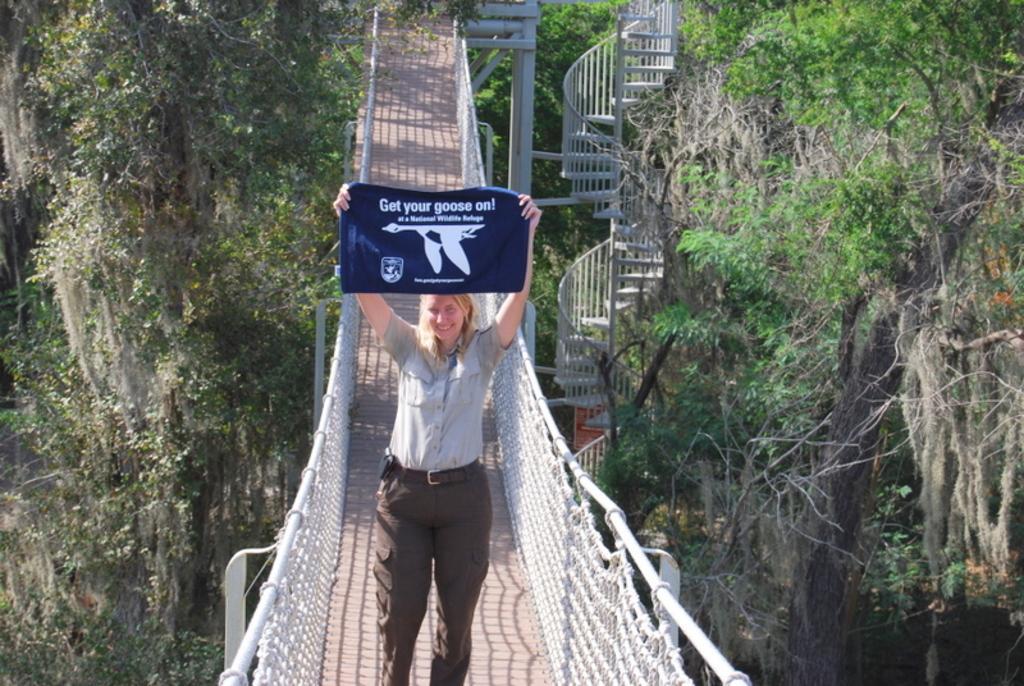In one or two sentences, can you explain what this image depicts? In this image, we can see a bridge in between trees. There is a person on the bridge wearing clothes and holding a banner with her hands. There are stairs in the middle of the image. 